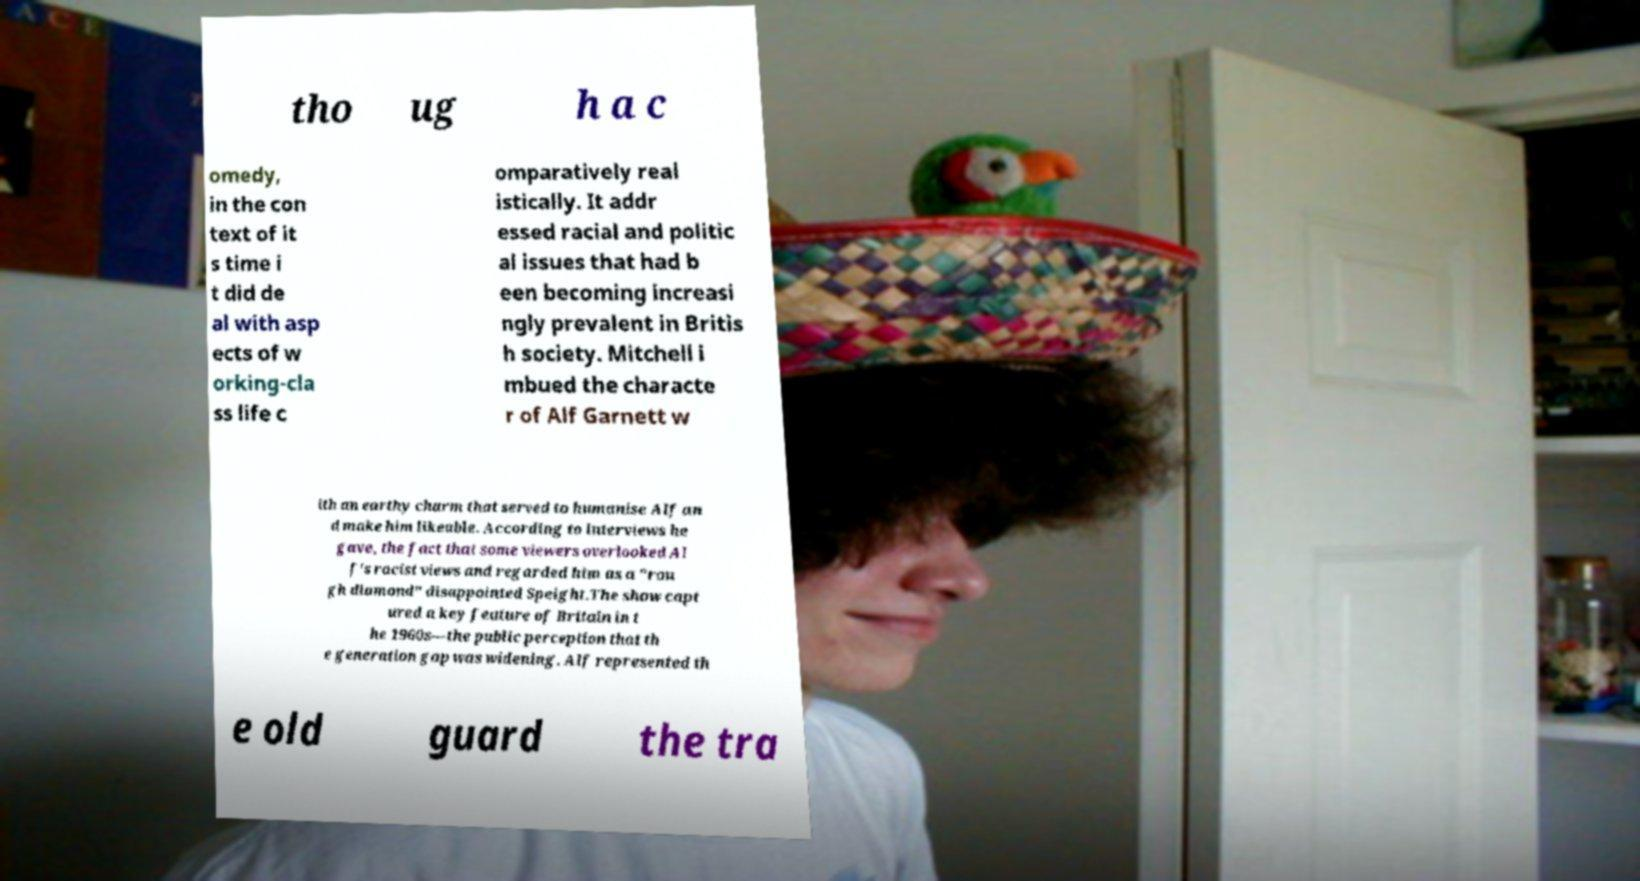There's text embedded in this image that I need extracted. Can you transcribe it verbatim? tho ug h a c omedy, in the con text of it s time i t did de al with asp ects of w orking-cla ss life c omparatively real istically. It addr essed racial and politic al issues that had b een becoming increasi ngly prevalent in Britis h society. Mitchell i mbued the characte r of Alf Garnett w ith an earthy charm that served to humanise Alf an d make him likeable. According to interviews he gave, the fact that some viewers overlooked Al f's racist views and regarded him as a "rou gh diamond" disappointed Speight.The show capt ured a key feature of Britain in t he 1960s—the public perception that th e generation gap was widening. Alf represented th e old guard the tra 